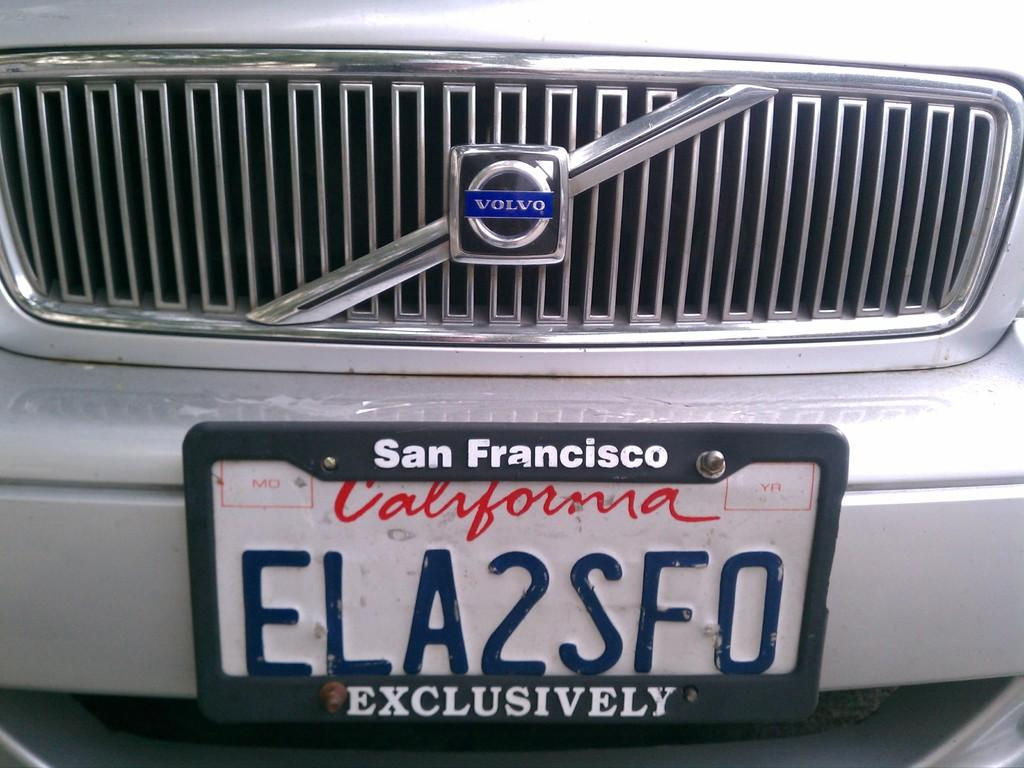Provide a one-sentence caption for the provided image. A close up is shown of the license plate "ELA2SFO" on a Volvo. 